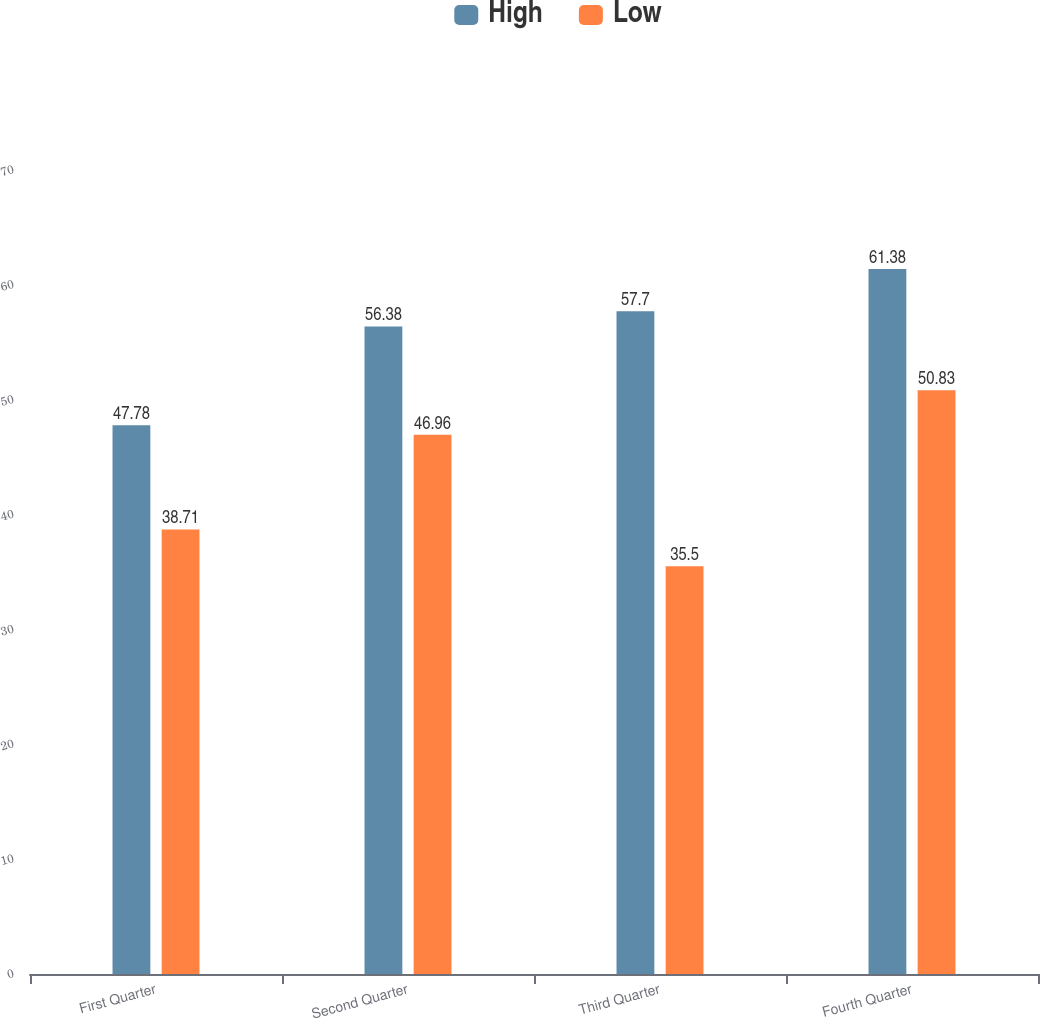<chart> <loc_0><loc_0><loc_500><loc_500><stacked_bar_chart><ecel><fcel>First Quarter<fcel>Second Quarter<fcel>Third Quarter<fcel>Fourth Quarter<nl><fcel>High<fcel>47.78<fcel>56.38<fcel>57.7<fcel>61.38<nl><fcel>Low<fcel>38.71<fcel>46.96<fcel>35.5<fcel>50.83<nl></chart> 